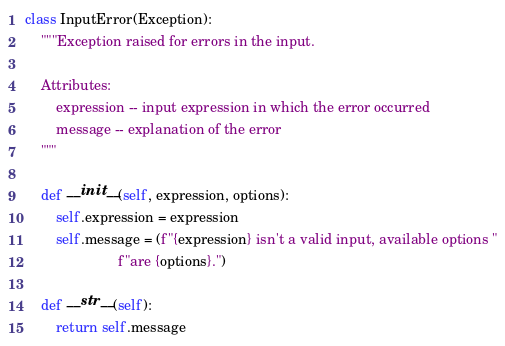<code> <loc_0><loc_0><loc_500><loc_500><_Python_>class InputError(Exception):
    """Exception raised for errors in the input.

    Attributes:
        expression -- input expression in which the error occurred
        message -- explanation of the error
    """

    def __init__(self, expression, options):
        self.expression = expression
        self.message = (f"{expression} isn't a valid input, available options "
                        f"are {options}.")

    def __str__(self):
        return self.message
</code> 